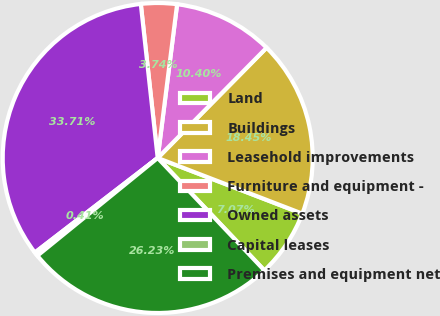Convert chart. <chart><loc_0><loc_0><loc_500><loc_500><pie_chart><fcel>Land<fcel>Buildings<fcel>Leasehold improvements<fcel>Furniture and equipment -<fcel>Owned assets<fcel>Capital leases<fcel>Premises and equipment net<nl><fcel>7.07%<fcel>18.45%<fcel>10.4%<fcel>3.74%<fcel>33.71%<fcel>0.41%<fcel>26.23%<nl></chart> 